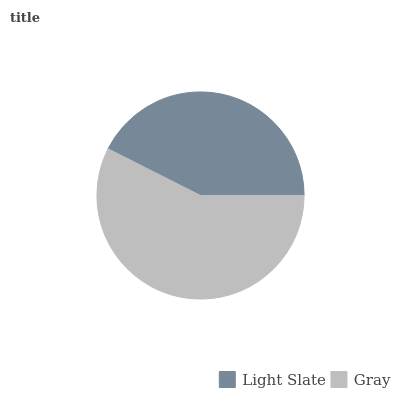Is Light Slate the minimum?
Answer yes or no. Yes. Is Gray the maximum?
Answer yes or no. Yes. Is Gray the minimum?
Answer yes or no. No. Is Gray greater than Light Slate?
Answer yes or no. Yes. Is Light Slate less than Gray?
Answer yes or no. Yes. Is Light Slate greater than Gray?
Answer yes or no. No. Is Gray less than Light Slate?
Answer yes or no. No. Is Gray the high median?
Answer yes or no. Yes. Is Light Slate the low median?
Answer yes or no. Yes. Is Light Slate the high median?
Answer yes or no. No. Is Gray the low median?
Answer yes or no. No. 